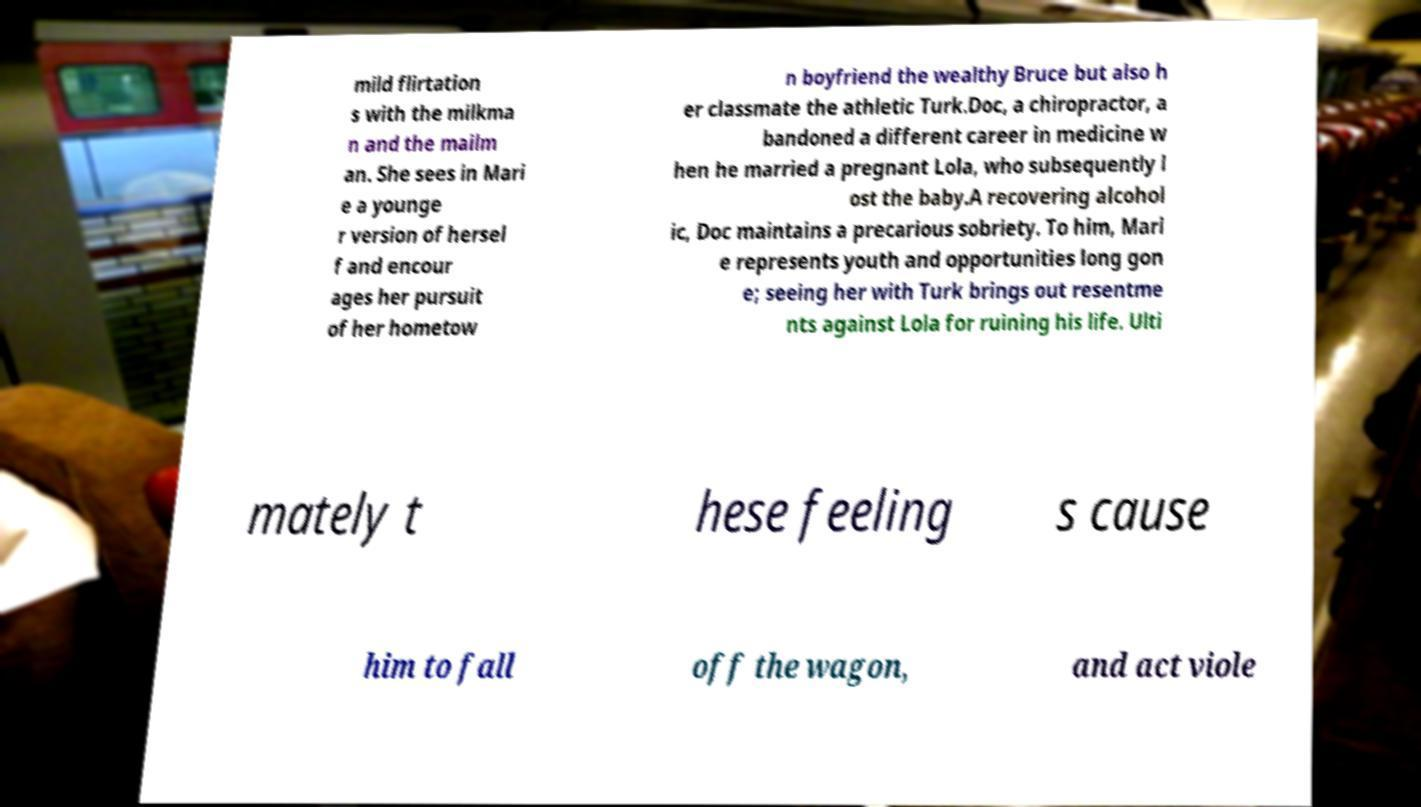Can you accurately transcribe the text from the provided image for me? mild flirtation s with the milkma n and the mailm an. She sees in Mari e a younge r version of hersel f and encour ages her pursuit of her hometow n boyfriend the wealthy Bruce but also h er classmate the athletic Turk.Doc, a chiropractor, a bandoned a different career in medicine w hen he married a pregnant Lola, who subsequently l ost the baby.A recovering alcohol ic, Doc maintains a precarious sobriety. To him, Mari e represents youth and opportunities long gon e; seeing her with Turk brings out resentme nts against Lola for ruining his life. Ulti mately t hese feeling s cause him to fall off the wagon, and act viole 